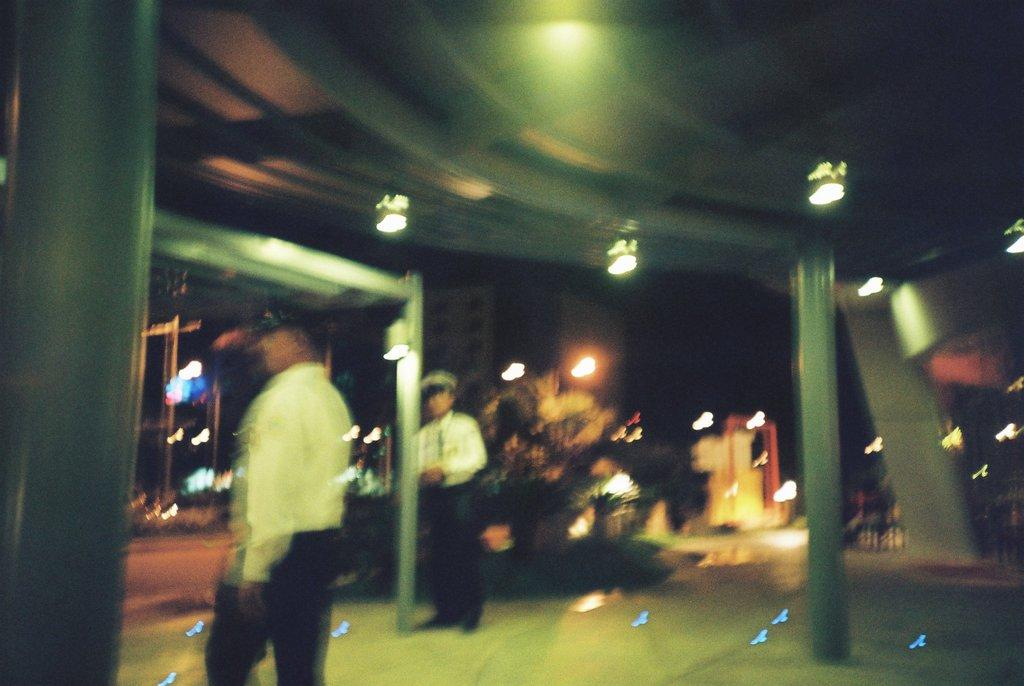How many people are present in the image? There are two persons standing in the image. What can be seen in the background of the image? There are lights, buildings, and trees visible in the image. What type of man-made structure is present in the image? There is a road in the image. What type of corn can be seen growing near the road in the image? There is no corn present in the image. Can you tell me how many tickets are visible in the image? There are no tickets visible in the image. 